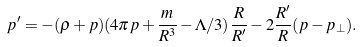<formula> <loc_0><loc_0><loc_500><loc_500>p ^ { \prime } = - ( \rho + p ) ( 4 \pi p + \frac { m } { R ^ { 3 } } - \Lambda / 3 ) \frac { R } { R ^ { \prime } } - 2 \frac { R ^ { \prime } } { R } ( p - p _ { \perp } ) .</formula> 